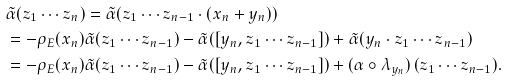Convert formula to latex. <formula><loc_0><loc_0><loc_500><loc_500>& \tilde { \alpha } ( z _ { 1 } \cdots z _ { n } ) = \tilde { \alpha } ( z _ { 1 } \cdots z _ { n - 1 } \cdot ( x _ { n } + y _ { n } ) ) \\ & = - \rho _ { E } ( x _ { n } ) \tilde { \alpha } ( z _ { 1 } \cdots z _ { n - 1 } ) - \tilde { \alpha } ( [ y _ { n } , z _ { 1 } \cdots z _ { n - 1 } ] ) + \tilde { \alpha } ( y _ { n } \cdot z _ { 1 } \cdots z _ { n - 1 } ) \\ & = - \rho _ { E } ( x _ { n } ) \tilde { \alpha } ( z _ { 1 } \cdots z _ { n - 1 } ) - \tilde { \alpha } ( [ y _ { n } , z _ { 1 } \cdots z _ { n - 1 } ] ) + ( \alpha \circ \lambda _ { y _ { n } } ) \, ( z _ { 1 } \cdots z _ { n - 1 } ) .</formula> 